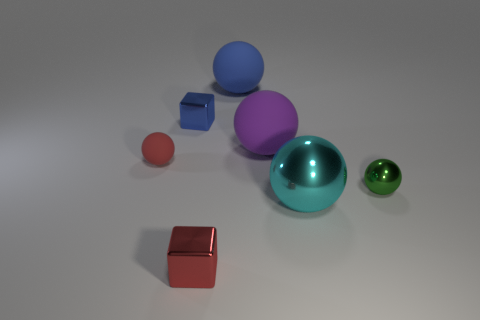What is the size of the object that is both to the left of the big blue object and behind the purple object?
Offer a terse response. Small. There is a cube in front of the purple matte thing; is its size the same as the matte sphere behind the purple rubber sphere?
Your answer should be compact. No. There is a blue thing that is the same shape as the green metallic thing; what is its material?
Offer a terse response. Rubber. Do the tiny rubber sphere and the small cube in front of the red matte object have the same color?
Provide a succinct answer. Yes. Does the small red thing that is in front of the green shiny ball have the same shape as the small blue metallic object?
Make the answer very short. Yes. Are there any green metallic spheres that have the same size as the purple sphere?
Keep it short and to the point. No. There is a tiny green thing; is its shape the same as the red thing that is in front of the green sphere?
Provide a succinct answer. No. What is the shape of the other tiny thing that is the same color as the small rubber object?
Offer a very short reply. Cube. Is the number of tiny blue things to the right of the tiny blue metallic object less than the number of brown objects?
Provide a short and direct response. No. Does the green metallic object have the same shape as the small red rubber thing?
Make the answer very short. Yes. 